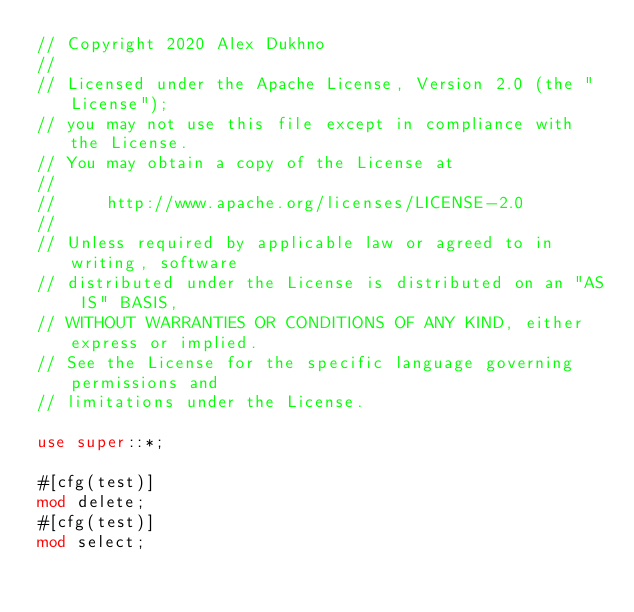<code> <loc_0><loc_0><loc_500><loc_500><_Rust_>// Copyright 2020 Alex Dukhno
//
// Licensed under the Apache License, Version 2.0 (the "License");
// you may not use this file except in compliance with the License.
// You may obtain a copy of the License at
//
//     http://www.apache.org/licenses/LICENSE-2.0
//
// Unless required by applicable law or agreed to in writing, software
// distributed under the License is distributed on an "AS IS" BASIS,
// WITHOUT WARRANTIES OR CONDITIONS OF ANY KIND, either express or implied.
// See the License for the specific language governing permissions and
// limitations under the License.

use super::*;

#[cfg(test)]
mod delete;
#[cfg(test)]
mod select;
</code> 